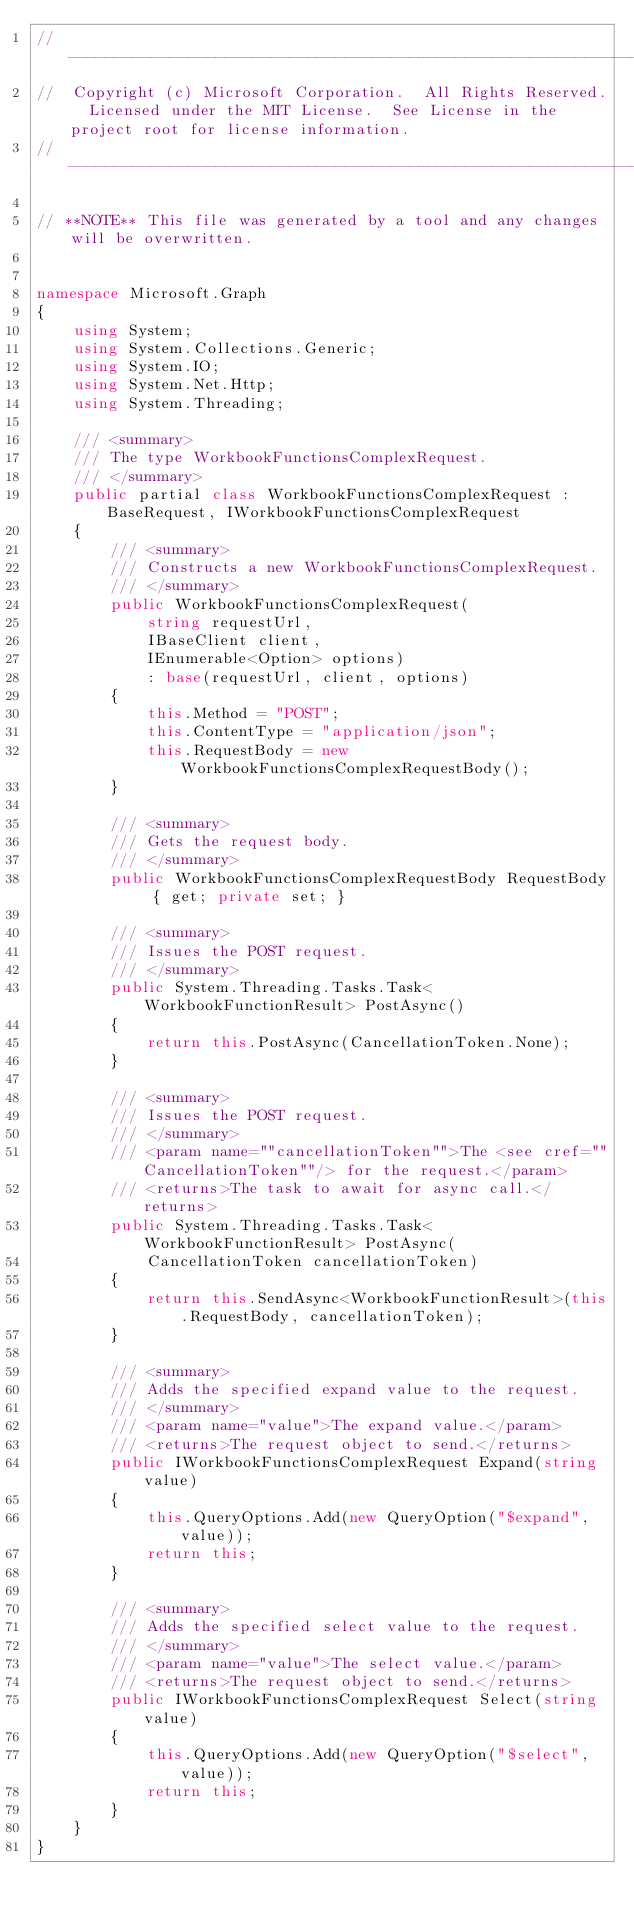Convert code to text. <code><loc_0><loc_0><loc_500><loc_500><_C#_>// ------------------------------------------------------------------------------
//  Copyright (c) Microsoft Corporation.  All Rights Reserved.  Licensed under the MIT License.  See License in the project root for license information.
// ------------------------------------------------------------------------------

// **NOTE** This file was generated by a tool and any changes will be overwritten.


namespace Microsoft.Graph
{
    using System;
    using System.Collections.Generic;
    using System.IO;
    using System.Net.Http;
    using System.Threading;

    /// <summary>
    /// The type WorkbookFunctionsComplexRequest.
    /// </summary>
    public partial class WorkbookFunctionsComplexRequest : BaseRequest, IWorkbookFunctionsComplexRequest
    {
        /// <summary>
        /// Constructs a new WorkbookFunctionsComplexRequest.
        /// </summary>
        public WorkbookFunctionsComplexRequest(
            string requestUrl,
            IBaseClient client,
            IEnumerable<Option> options)
            : base(requestUrl, client, options)
        {
            this.Method = "POST";
            this.ContentType = "application/json";
            this.RequestBody = new WorkbookFunctionsComplexRequestBody();
        }

        /// <summary>
        /// Gets the request body.
        /// </summary>
        public WorkbookFunctionsComplexRequestBody RequestBody { get; private set; }

        /// <summary>
        /// Issues the POST request.
        /// </summary>
        public System.Threading.Tasks.Task<WorkbookFunctionResult> PostAsync()
        {
            return this.PostAsync(CancellationToken.None);
        }

        /// <summary>
        /// Issues the POST request.
        /// </summary>
        /// <param name=""cancellationToken"">The <see cref=""CancellationToken""/> for the request.</param>
        /// <returns>The task to await for async call.</returns>
        public System.Threading.Tasks.Task<WorkbookFunctionResult> PostAsync(
            CancellationToken cancellationToken)
        {
            return this.SendAsync<WorkbookFunctionResult>(this.RequestBody, cancellationToken);
        }

        /// <summary>
        /// Adds the specified expand value to the request.
        /// </summary>
        /// <param name="value">The expand value.</param>
        /// <returns>The request object to send.</returns>
        public IWorkbookFunctionsComplexRequest Expand(string value)
        {
            this.QueryOptions.Add(new QueryOption("$expand", value));
            return this;
        }

        /// <summary>
        /// Adds the specified select value to the request.
        /// </summary>
        /// <param name="value">The select value.</param>
        /// <returns>The request object to send.</returns>
        public IWorkbookFunctionsComplexRequest Select(string value)
        {
            this.QueryOptions.Add(new QueryOption("$select", value));
            return this;
        }
    }
}
</code> 